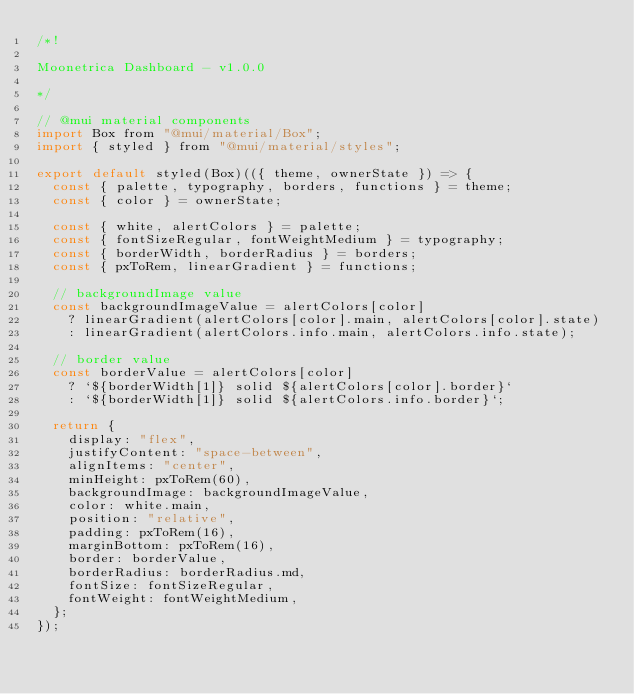Convert code to text. <code><loc_0><loc_0><loc_500><loc_500><_JavaScript_>/*!

Moonetrica Dashboard - v1.0.0

*/

// @mui material components
import Box from "@mui/material/Box";
import { styled } from "@mui/material/styles";

export default styled(Box)(({ theme, ownerState }) => {
  const { palette, typography, borders, functions } = theme;
  const { color } = ownerState;

  const { white, alertColors } = palette;
  const { fontSizeRegular, fontWeightMedium } = typography;
  const { borderWidth, borderRadius } = borders;
  const { pxToRem, linearGradient } = functions;

  // backgroundImage value
  const backgroundImageValue = alertColors[color]
    ? linearGradient(alertColors[color].main, alertColors[color].state)
    : linearGradient(alertColors.info.main, alertColors.info.state);

  // border value
  const borderValue = alertColors[color]
    ? `${borderWidth[1]} solid ${alertColors[color].border}`
    : `${borderWidth[1]} solid ${alertColors.info.border}`;

  return {
    display: "flex",
    justifyContent: "space-between",
    alignItems: "center",
    minHeight: pxToRem(60),
    backgroundImage: backgroundImageValue,
    color: white.main,
    position: "relative",
    padding: pxToRem(16),
    marginBottom: pxToRem(16),
    border: borderValue,
    borderRadius: borderRadius.md,
    fontSize: fontSizeRegular,
    fontWeight: fontWeightMedium,
  };
});
</code> 